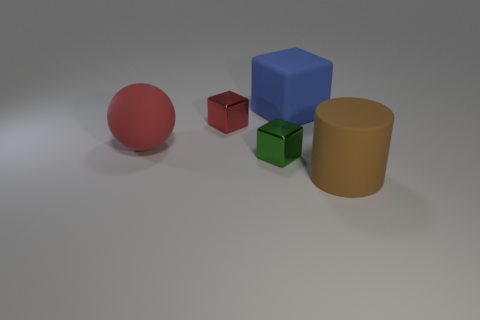Add 4 big brown cubes. How many objects exist? 9 Subtract all tiny green metallic cubes. How many cubes are left? 2 Subtract 1 cubes. How many cubes are left? 2 Subtract all cubes. How many objects are left? 2 Subtract 0 purple cylinders. How many objects are left? 5 Subtract all gray blocks. Subtract all green spheres. How many blocks are left? 3 Subtract all large red balls. Subtract all blue rubber blocks. How many objects are left? 3 Add 1 cylinders. How many cylinders are left? 2 Add 2 big blue metallic cubes. How many big blue metallic cubes exist? 2 